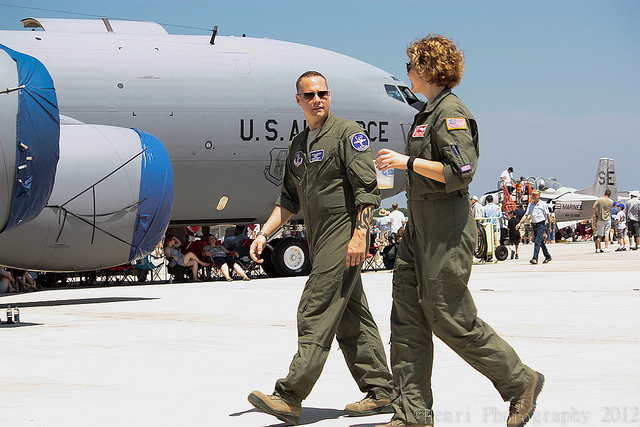Please transcribe the text information in this image. U. S. 2012 PHOTOGRAPHY C HENRI MARNES SE 